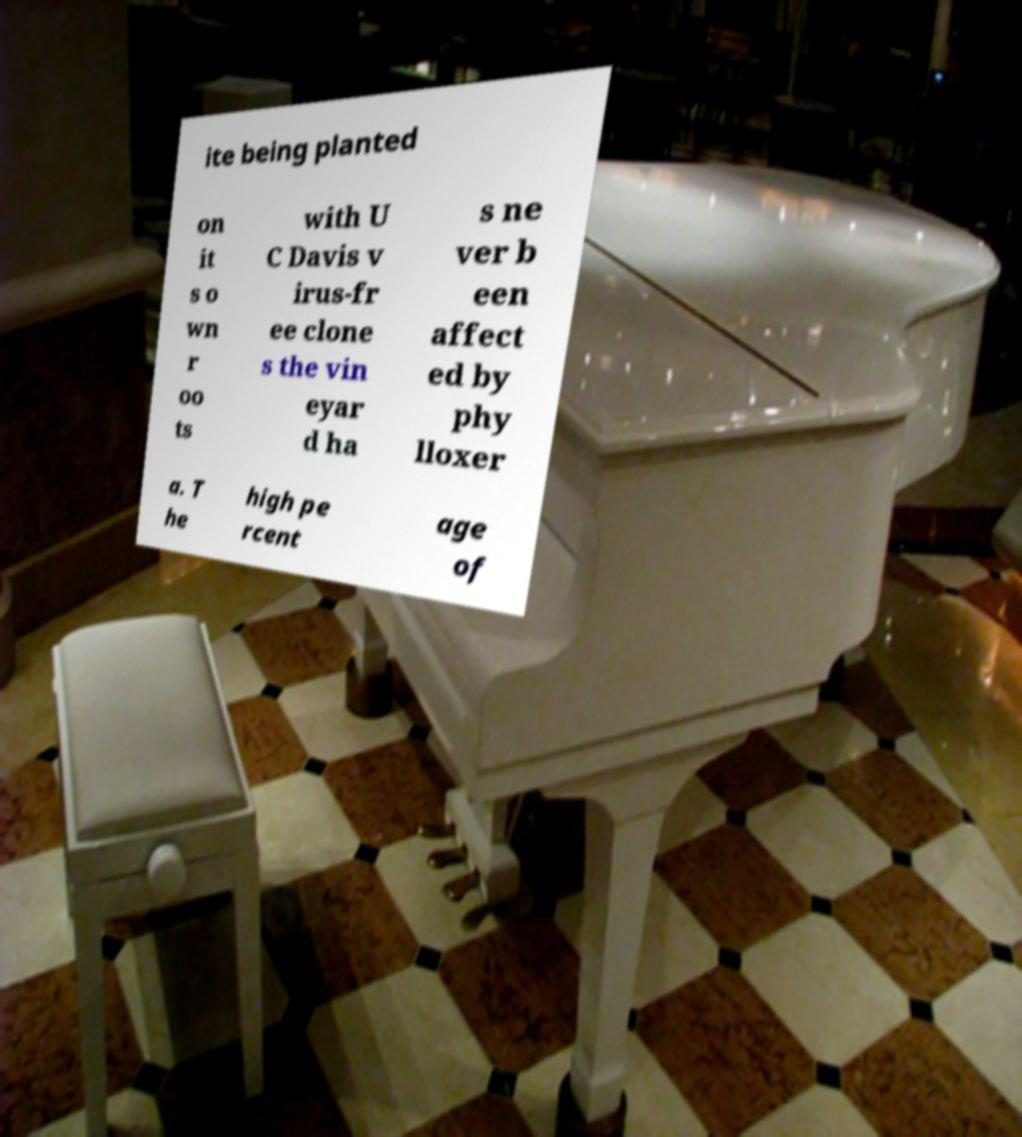There's text embedded in this image that I need extracted. Can you transcribe it verbatim? ite being planted on it s o wn r oo ts with U C Davis v irus-fr ee clone s the vin eyar d ha s ne ver b een affect ed by phy lloxer a. T he high pe rcent age of 